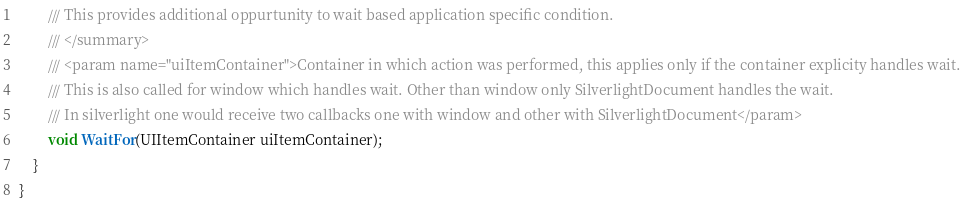Convert code to text. <code><loc_0><loc_0><loc_500><loc_500><_C#_>        /// This provides additional oppurtunity to wait based application specific condition.
        /// </summary>
        /// <param name="uiItemContainer">Container in which action was performed, this applies only if the container explicity handles wait. 
        /// This is also called for window which handles wait. Other than window only SilverlightDocument handles the wait.
        /// In silverlight one would receive two callbacks one with window and other with SilverlightDocument</param>
        void WaitFor(UIItemContainer uiItemContainer);
    }
}</code> 